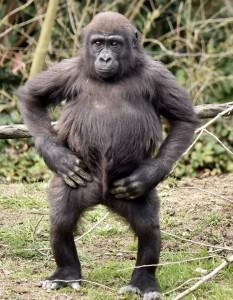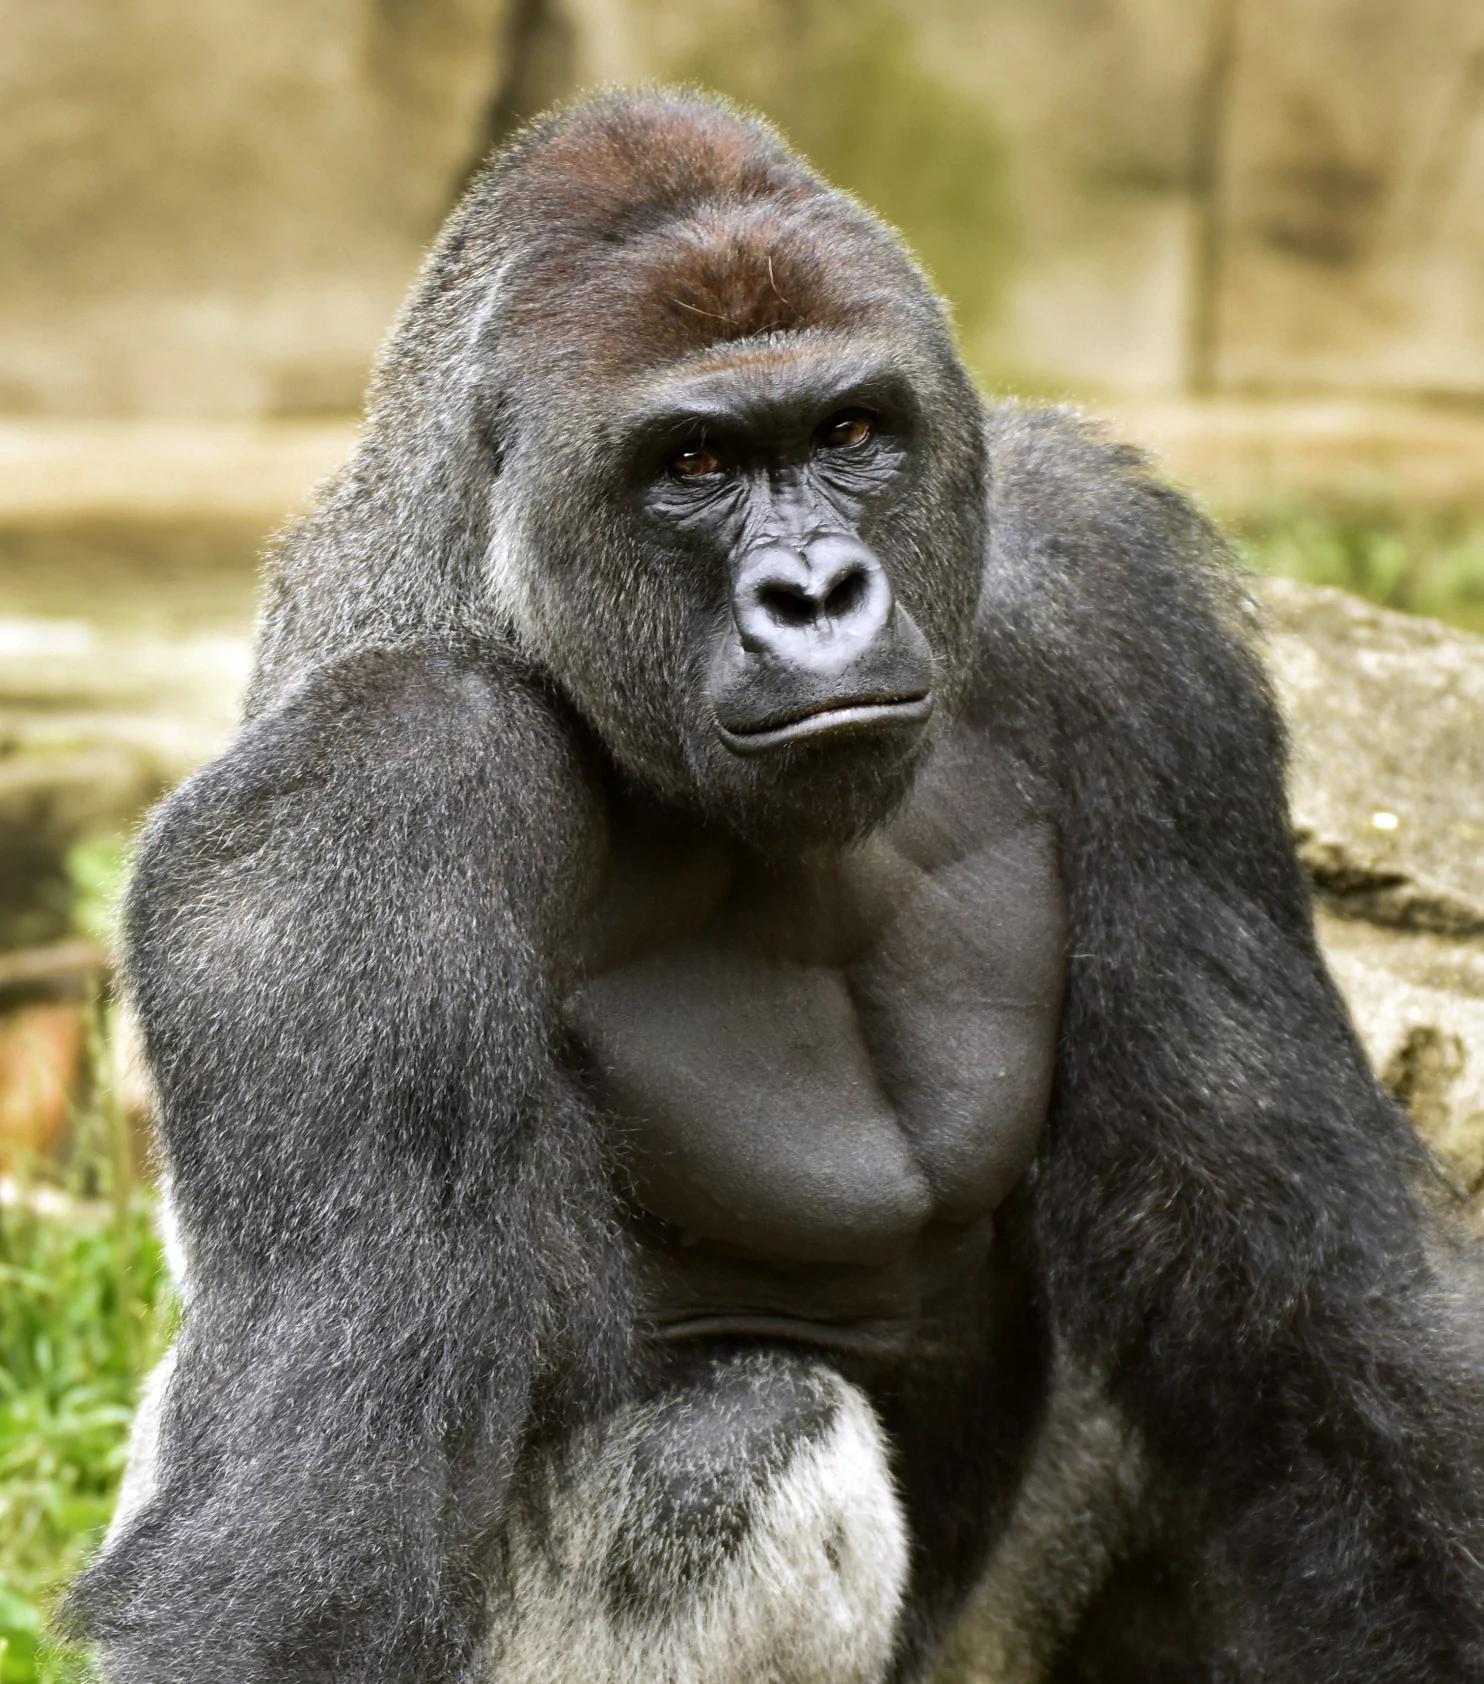The first image is the image on the left, the second image is the image on the right. For the images shown, is this caption "An image shows three gorillas of different sizes." true? Answer yes or no. No. The first image is the image on the left, the second image is the image on the right. Considering the images on both sides, is "There is exactly one animal in the image on the left." valid? Answer yes or no. Yes. 